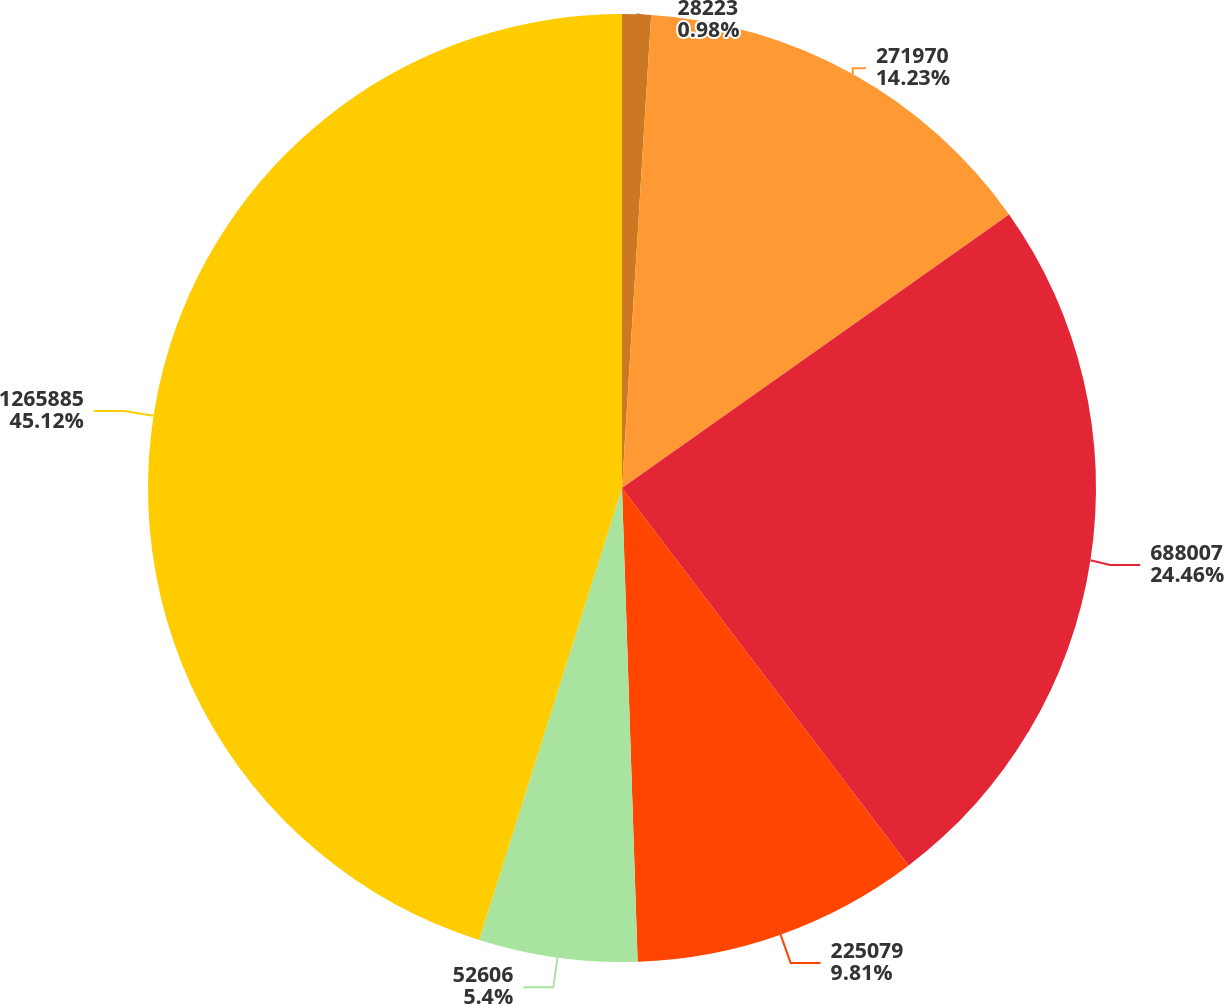<chart> <loc_0><loc_0><loc_500><loc_500><pie_chart><fcel>28223<fcel>271970<fcel>688007<fcel>225079<fcel>52606<fcel>1265885<nl><fcel>0.98%<fcel>14.23%<fcel>24.46%<fcel>9.81%<fcel>5.4%<fcel>45.13%<nl></chart> 